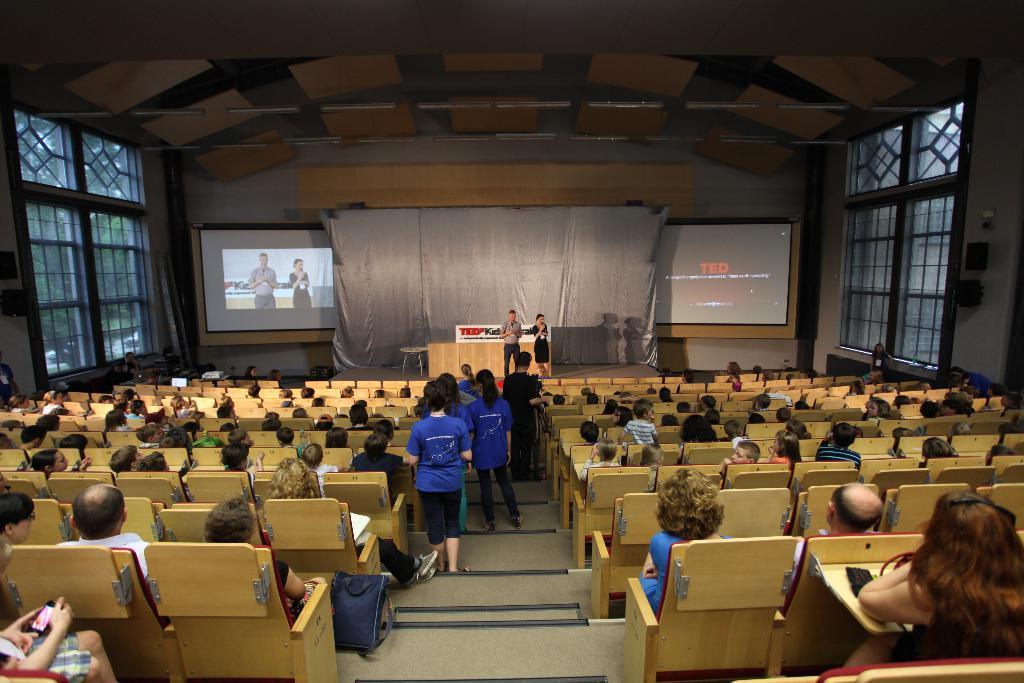Please provide a concise description of this image. In this image there are group of people sitting on the chairs, group of people standing, stage, table, chair,screens, windows, speakers. 